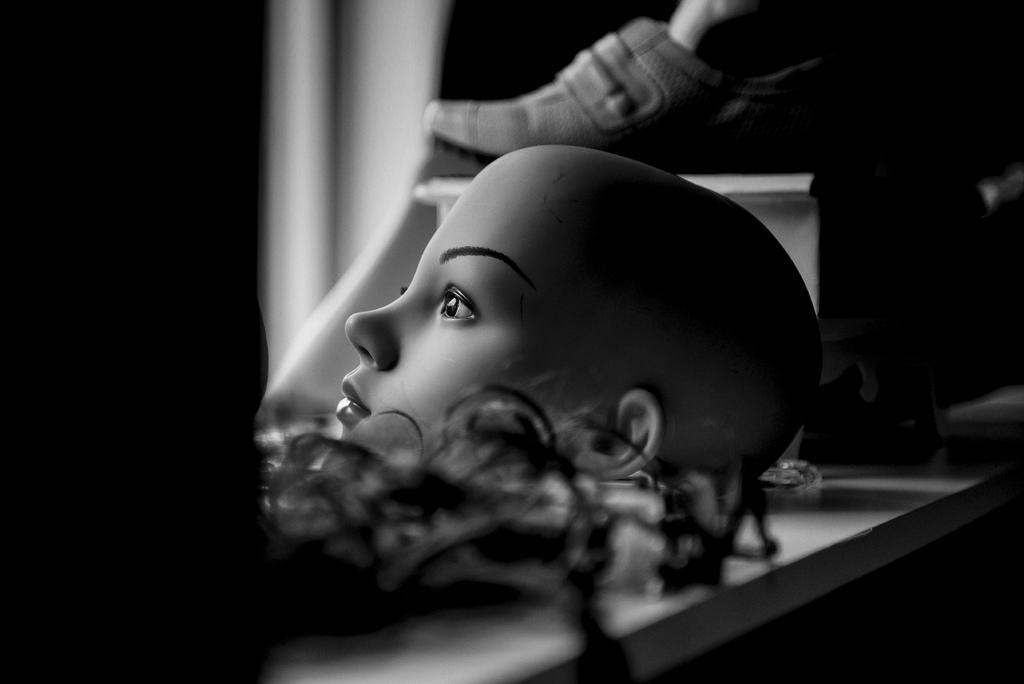What is the color scheme of the image? The image is black and white. What is the main subject of the image? There is a mannequin head in the image. What else can be seen in the image besides the mannequin head? There is a shoe in the image. Can you describe the mannequin head's appearance? The mannequin head appears to have hair. Where are the objects located in the image? The objects are on a table. How would you describe the background of the image? The background of the image is blurry. Can you see any hills in the background of the image? There are no hills visible in the background of the image; it is blurry and does not show any landscape features. Is there a hose or pipe present in the image? There is no hose or pipe present in the image; it only features a mannequin head, a shoe, and a blurry background. 